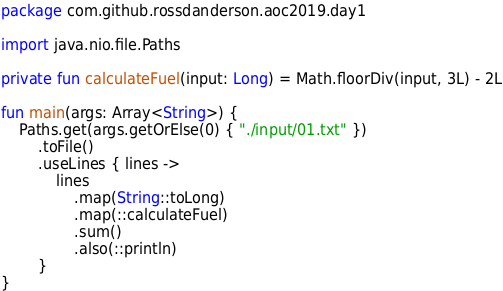<code> <loc_0><loc_0><loc_500><loc_500><_Kotlin_>package com.github.rossdanderson.aoc2019.day1

import java.nio.file.Paths

private fun calculateFuel(input: Long) = Math.floorDiv(input, 3L) - 2L

fun main(args: Array<String>) {
    Paths.get(args.getOrElse(0) { "./input/01.txt" })
        .toFile()
        .useLines { lines ->
            lines
                .map(String::toLong)
                .map(::calculateFuel)
                .sum()
                .also(::println)
        }
}
</code> 